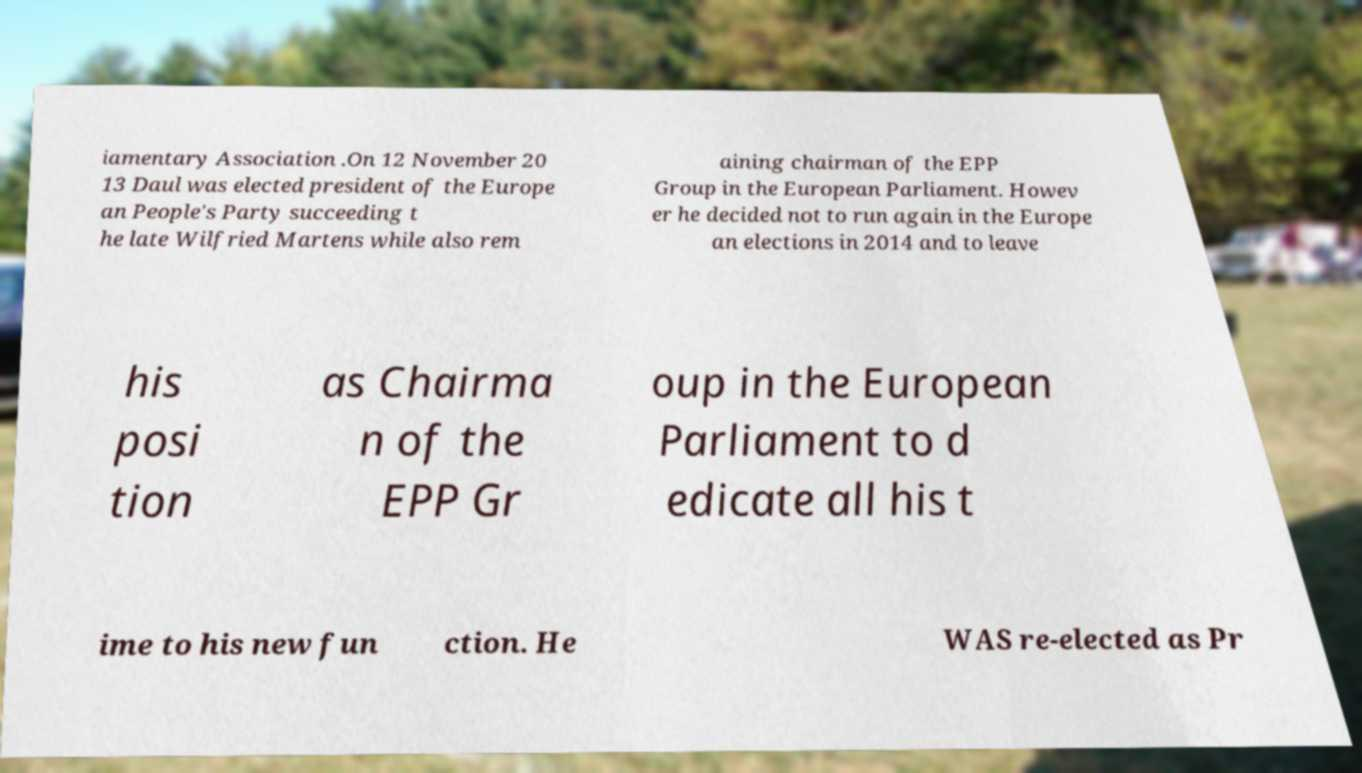Please identify and transcribe the text found in this image. iamentary Association .On 12 November 20 13 Daul was elected president of the Europe an People's Party succeeding t he late Wilfried Martens while also rem aining chairman of the EPP Group in the European Parliament. Howev er he decided not to run again in the Europe an elections in 2014 and to leave his posi tion as Chairma n of the EPP Gr oup in the European Parliament to d edicate all his t ime to his new fun ction. He WAS re-elected as Pr 